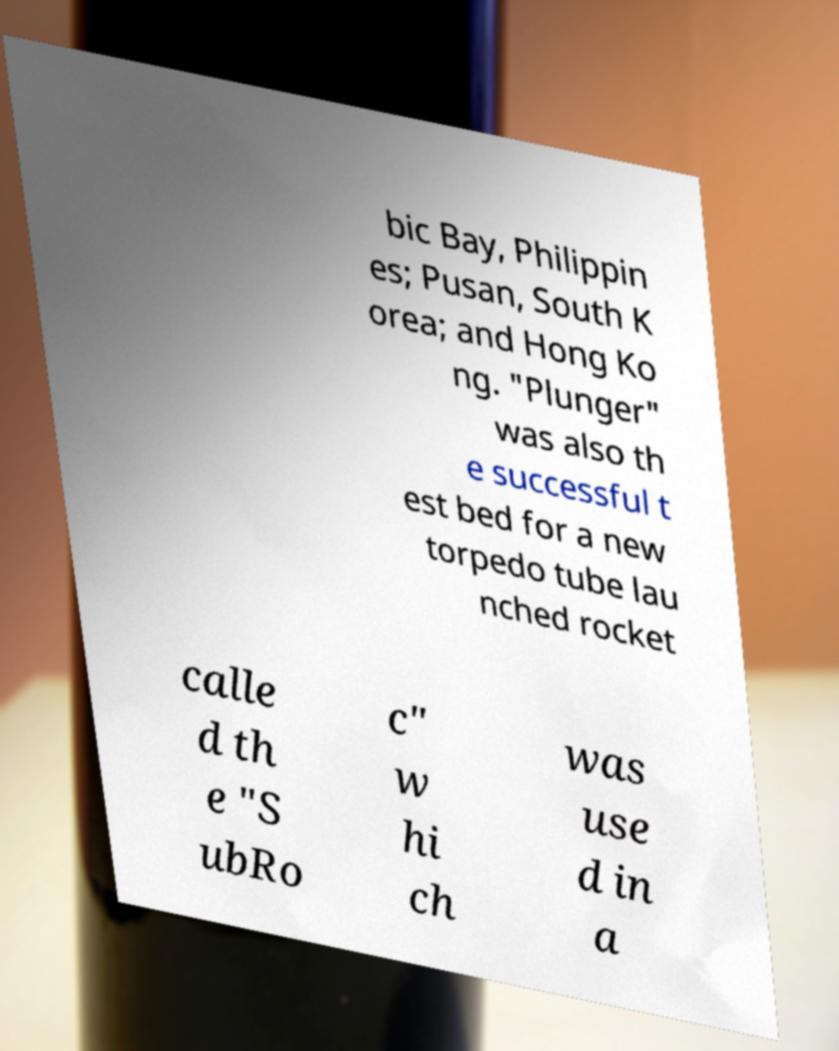For documentation purposes, I need the text within this image transcribed. Could you provide that? bic Bay, Philippin es; Pusan, South K orea; and Hong Ko ng. "Plunger" was also th e successful t est bed for a new torpedo tube lau nched rocket calle d th e "S ubRo c" w hi ch was use d in a 